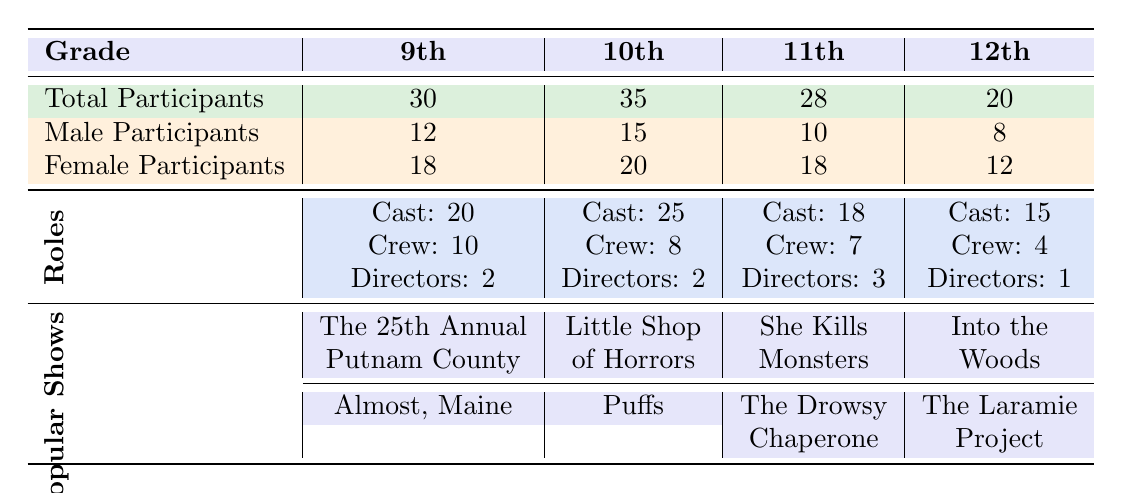What is the total number of participants in 10th grade? The table shows that under the 10th grade, the total number of participants listed is 35.
Answer: 35 How many female participants are there in 11th grade? Referring to the 11th grade section of the table, the number of female participants is shown as 18.
Answer: 18 What is the total number of participants in all grades combined? By adding the total participants from all grades: 30 (9th) + 35 (10th) + 28 (11th) + 20 (12th) = 113.
Answer: 113 Which grade has the highest number of male participants? Looking at the male participants across grades: 12 in 9th, 15 in 10th, 10 in 11th, and 8 in 12th. The highest is 15 in 10th grade.
Answer: 10th grade Are there more female participants than male participants in 12th grade? In 12th grade, there are 12 female participants and 8 male participants. Since 12 is greater than 8, the statement is true.
Answer: Yes What is the difference in total participants between 9th grade and 12th grade? The total participants in 9th grade are 30, and in 12th grade are 20. The difference is 30 - 20 = 10.
Answer: 10 Which show is popular among 9th graders? The popular shows listed for 9th graders are "The 25th Annual Putnam County Spelling Bee" and "Almost, Maine". Both are considered popular shows.
Answer: The 25th Annual Putnam County Spelling Bee, Almost, Maine If we look at the cast roles, which grade has the least number of cast members? The table shows cast members as follows: 20 in 9th, 25 in 10th, 18 in 11th, and 15 in 12th. The least is 15 in 12th grade.
Answer: 12th grade What percentage of the total participants in 10th grade are male? There are 15 male participants out of a total of 35. To find the percentage, (15/35)*100 = 42.86%.
Answer: 42.86% What are the popular shows performed by 11th graders? For 11th grade, the popular shows listed are "She Kills Monsters" and "The Drowsy Chaperone".
Answer: She Kills Monsters, The Drowsy Chaperone 